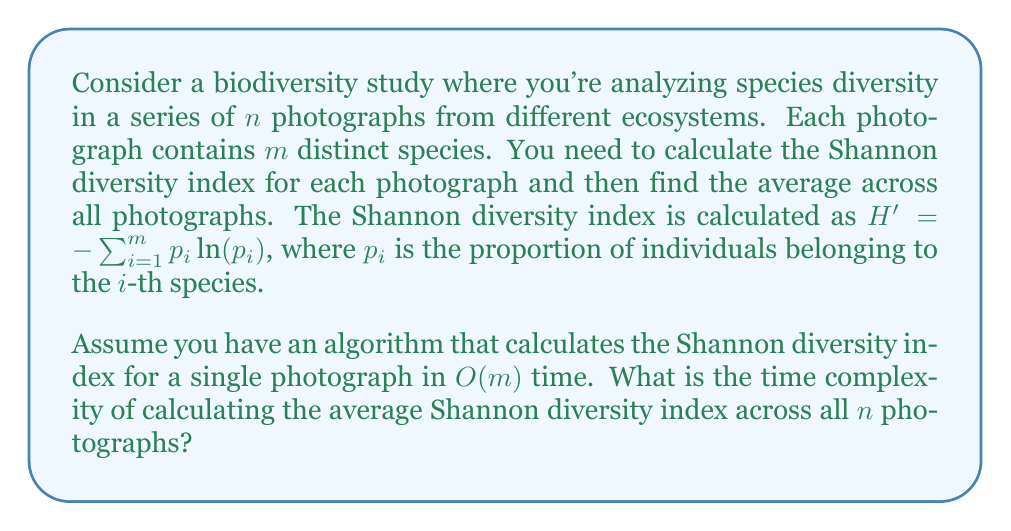Can you answer this question? Let's break down the problem and analyze it step by step:

1. For each photograph, we need to calculate the Shannon diversity index.
   - This takes $O(m)$ time for each photograph, as given in the question.

2. We need to do this calculation for all $n$ photographs.
   - This means we're performing an $O(m)$ operation $n$ times.

3. The time complexity for calculating all indices is therefore $O(n \cdot m)$.

4. After calculating all indices, we need to sum them up and divide by $n$ to get the average.
   - Summing $n$ values takes $O(n)$ time.
   - Division is a constant time operation, $O(1)$.

5. The total time complexity is the sum of these operations:
   $O(n \cdot m) + O(n) + O(1)$

6. In Big O notation, we only consider the most significant term, which in this case is $O(n \cdot m)$.

Therefore, the overall time complexity of the algorithm is $O(n \cdot m)$.

This makes sense intuitively: we're processing $n$ photographs, each containing $m$ species, so we're effectively touching each species in each photograph once.
Answer: $O(n \cdot m)$ 